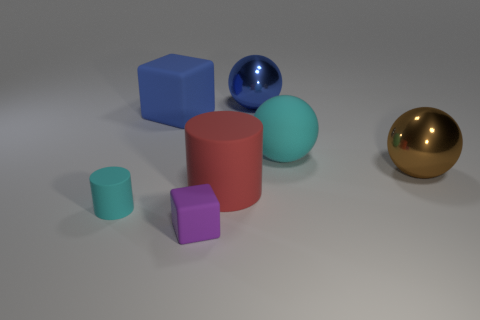What is the size of the blue object to the left of the purple block?
Your response must be concise. Large. Are there more cyan cylinders than cyan rubber things?
Make the answer very short. No. What material is the brown thing?
Offer a very short reply. Metal. What number of other things are there of the same material as the blue cube
Your response must be concise. 4. How many tiny purple things are there?
Your answer should be very brief. 1. What material is the blue object that is the same shape as the large brown metallic object?
Provide a succinct answer. Metal. Are the cylinder on the left side of the big matte cylinder and the purple block made of the same material?
Make the answer very short. Yes. Is the number of large blue matte things in front of the large brown thing greater than the number of purple rubber things left of the purple object?
Offer a terse response. No. What size is the brown ball?
Make the answer very short. Large. The tiny purple thing that is the same material as the large block is what shape?
Give a very brief answer. Cube. 